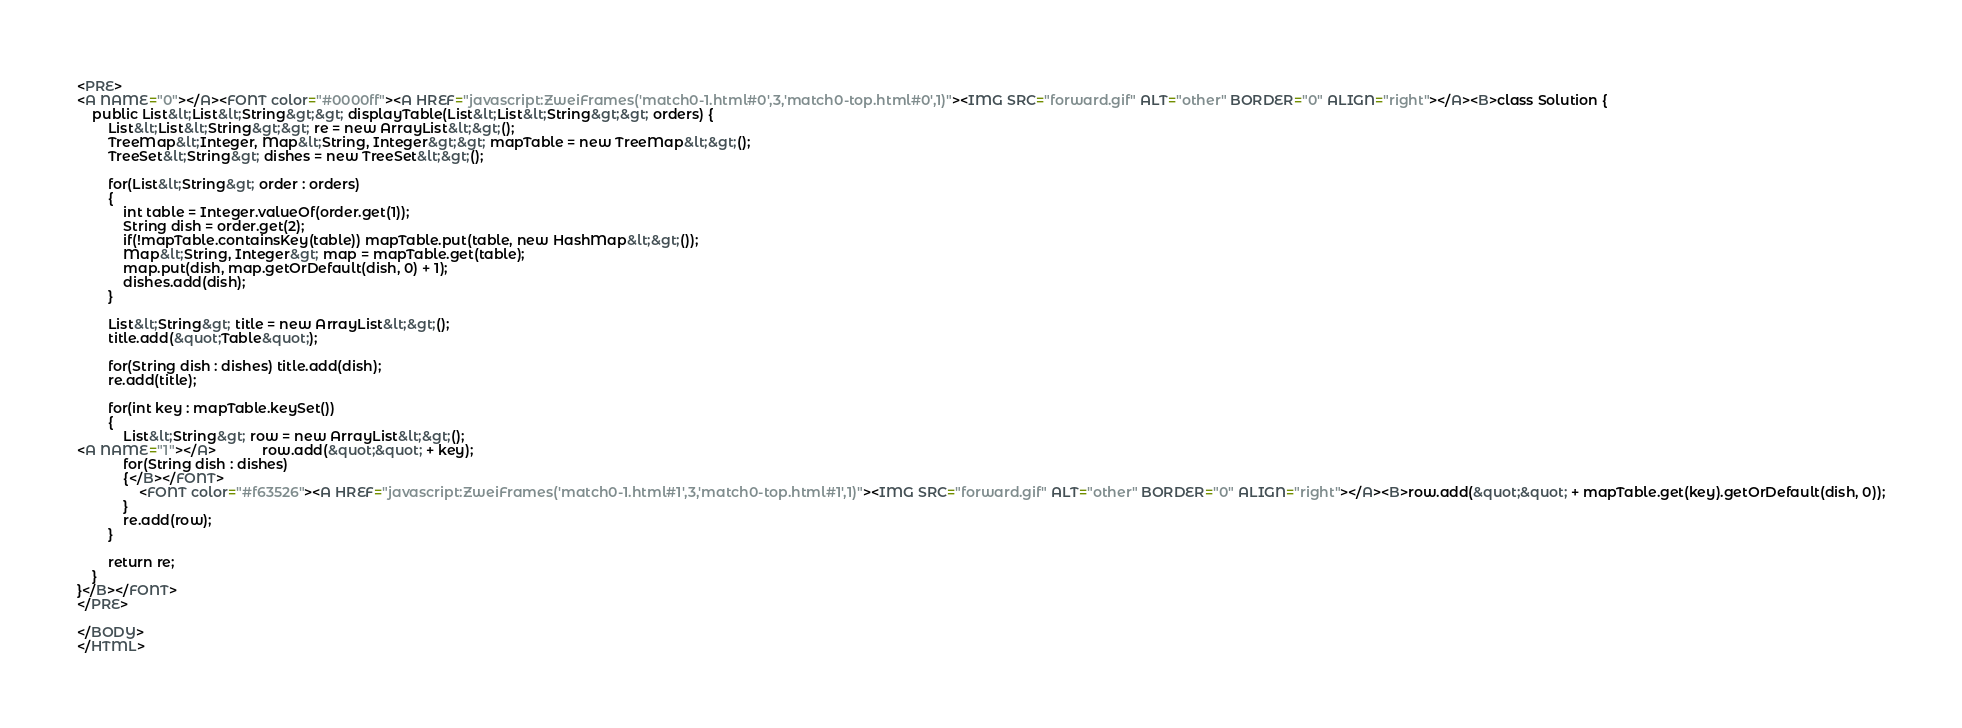Convert code to text. <code><loc_0><loc_0><loc_500><loc_500><_HTML_><PRE>
<A NAME="0"></A><FONT color="#0000ff"><A HREF="javascript:ZweiFrames('match0-1.html#0',3,'match0-top.html#0',1)"><IMG SRC="forward.gif" ALT="other" BORDER="0" ALIGN="right"></A><B>class Solution {
    public List&lt;List&lt;String&gt;&gt; displayTable(List&lt;List&lt;String&gt;&gt; orders) {
        List&lt;List&lt;String&gt;&gt; re = new ArrayList&lt;&gt;();
        TreeMap&lt;Integer, Map&lt;String, Integer&gt;&gt; mapTable = new TreeMap&lt;&gt;();
        TreeSet&lt;String&gt; dishes = new TreeSet&lt;&gt;();
        
        for(List&lt;String&gt; order : orders)
        {
            int table = Integer.valueOf(order.get(1));
            String dish = order.get(2);
            if(!mapTable.containsKey(table)) mapTable.put(table, new HashMap&lt;&gt;());
            Map&lt;String, Integer&gt; map = mapTable.get(table);
            map.put(dish, map.getOrDefault(dish, 0) + 1);
            dishes.add(dish);
        }

        List&lt;String&gt; title = new ArrayList&lt;&gt;();
        title.add(&quot;Table&quot;);
        
        for(String dish : dishes) title.add(dish);
        re.add(title);
        
        for(int key : mapTable.keySet())
        {
            List&lt;String&gt; row = new ArrayList&lt;&gt;();
<A NAME="1"></A>            row.add(&quot;&quot; + key);
            for(String dish : dishes)
            {</B></FONT>
                <FONT color="#f63526"><A HREF="javascript:ZweiFrames('match0-1.html#1',3,'match0-top.html#1',1)"><IMG SRC="forward.gif" ALT="other" BORDER="0" ALIGN="right"></A><B>row.add(&quot;&quot; + mapTable.get(key).getOrDefault(dish, 0));
            }
            re.add(row);
        }

        return re;
    }    
}</B></FONT>
</PRE>

</BODY>
</HTML>
</code> 